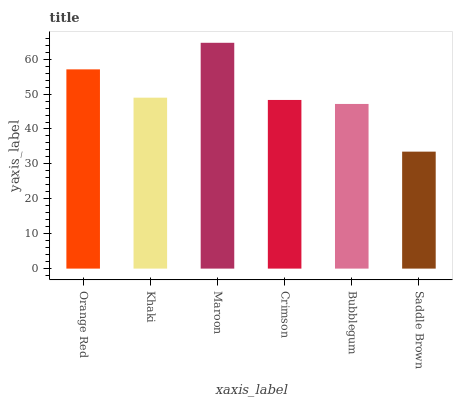Is Saddle Brown the minimum?
Answer yes or no. Yes. Is Maroon the maximum?
Answer yes or no. Yes. Is Khaki the minimum?
Answer yes or no. No. Is Khaki the maximum?
Answer yes or no. No. Is Orange Red greater than Khaki?
Answer yes or no. Yes. Is Khaki less than Orange Red?
Answer yes or no. Yes. Is Khaki greater than Orange Red?
Answer yes or no. No. Is Orange Red less than Khaki?
Answer yes or no. No. Is Khaki the high median?
Answer yes or no. Yes. Is Crimson the low median?
Answer yes or no. Yes. Is Maroon the high median?
Answer yes or no. No. Is Saddle Brown the low median?
Answer yes or no. No. 